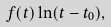Convert formula to latex. <formula><loc_0><loc_0><loc_500><loc_500>f ( t ) \ln ( t - t _ { 0 } ) ,</formula> 